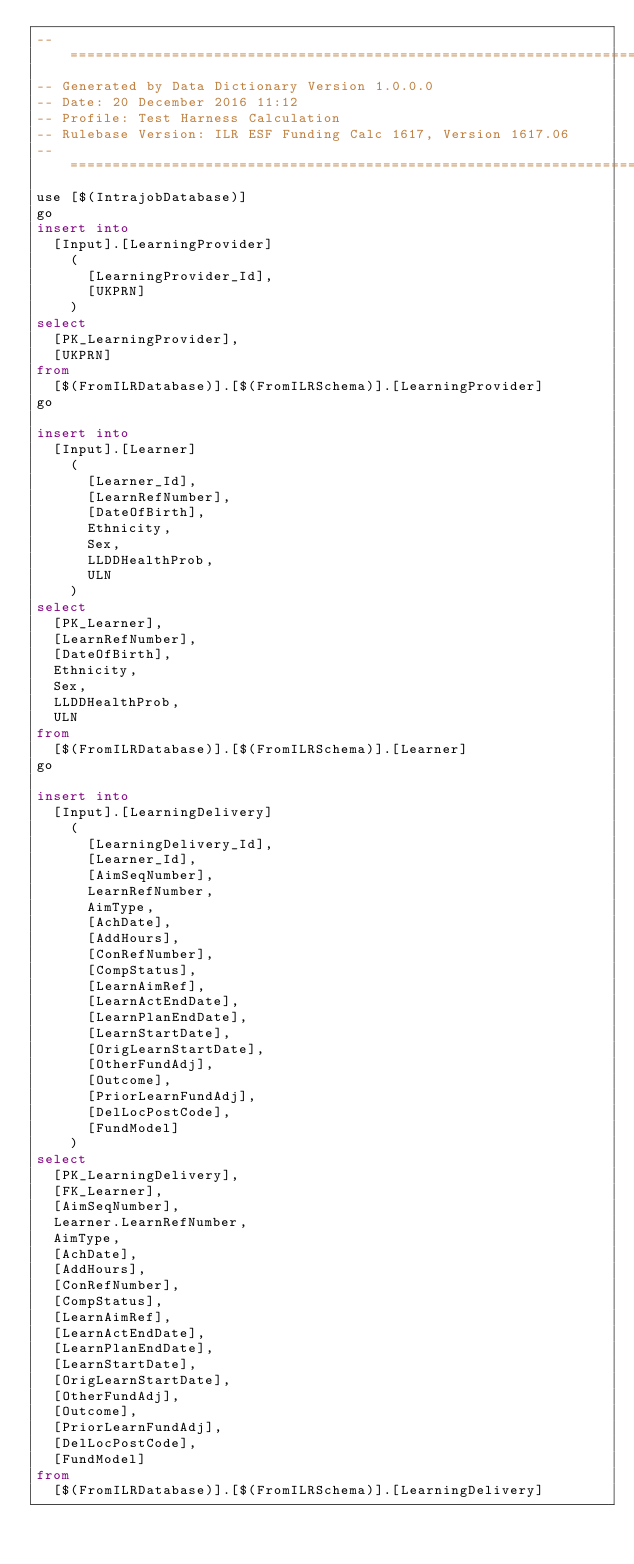<code> <loc_0><loc_0><loc_500><loc_500><_SQL_>-- =====================================================================================================
-- Generated by Data Dictionary Version 1.0.0.0
-- Date: 20 December 2016 11:12
-- Profile: Test Harness Calculation
-- Rulebase Version: ILR ESF Funding Calc 1617, Version 1617.06
-- =====================================================================================================
use [$(IntrajobDatabase)]
go
insert into
	[Input].[LearningProvider]
		(
			[LearningProvider_Id],
			[UKPRN]
		)
select
	[PK_LearningProvider],
	[UKPRN]
from
	[$(FromILRDatabase)].[$(FromILRSchema)].[LearningProvider]
go

insert into
	[Input].[Learner]
		(
			[Learner_Id],
			[LearnRefNumber],
			[DateOfBirth],
			Ethnicity,
			Sex,
			LLDDHealthProb,
			ULN
		)
select
	[PK_Learner],
	[LearnRefNumber],
	[DateOfBirth],
	Ethnicity,
	Sex,
	LLDDHealthProb,
	ULN
from
	[$(FromILRDatabase)].[$(FromILRSchema)].[Learner]
go

insert into
	[Input].[LearningDelivery]
		(
			[LearningDelivery_Id],
			[Learner_Id],
			[AimSeqNumber],
			LearnRefNumber,
			AimType,
			[AchDate],
			[AddHours],
			[ConRefNumber],
			[CompStatus],
			[LearnAimRef],
			[LearnActEndDate],
			[LearnPlanEndDate],
			[LearnStartDate],
			[OrigLearnStartDate],
			[OtherFundAdj],
			[Outcome],
			[PriorLearnFundAdj],
			[DelLocPostCode],
			[FundModel]
		)
select
	[PK_LearningDelivery],
	[FK_Learner],
	[AimSeqNumber],
	Learner.LearnRefNumber,
	AimType,
	[AchDate],
	[AddHours],
	[ConRefNumber],
	[CompStatus],
	[LearnAimRef],
	[LearnActEndDate],
	[LearnPlanEndDate],
	[LearnStartDate],
	[OrigLearnStartDate],
	[OtherFundAdj],
	[Outcome],
	[PriorLearnFundAdj],
	[DelLocPostCode],
	[FundModel]
from
	[$(FromILRDatabase)].[$(FromILRSchema)].[LearningDelivery]</code> 